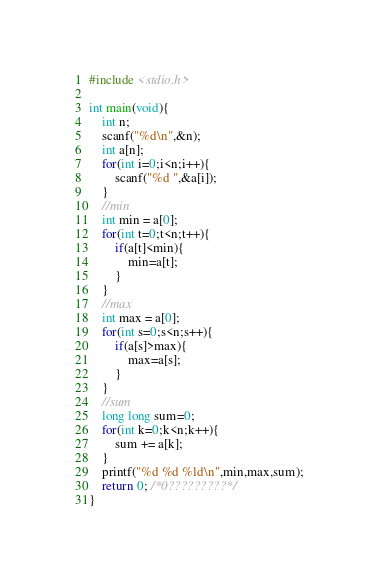Convert code to text. <code><loc_0><loc_0><loc_500><loc_500><_C_>#include <stdio.h>

int main(void){
    int n;
    scanf("%d\n",&n);
    int a[n];
    for(int i=0;i<n;i++){
        scanf("%d ",&a[i]);
    }
    //min
    int min = a[0];
    for(int t=0;t<n;t++){
        if(a[t]<min){
            min=a[t];
        }
    }
    //max
    int max = a[0];
    for(int s=0;s<n;s++){
        if(a[s]>max){
            max=a[s];
        }
    }
    //sum
    long long sum=0;
    for(int k=0;k<n;k++){
        sum += a[k];
    }
    printf("%d %d %ld\n",min,max,sum);
    return 0; /*0?????????*/
}</code> 